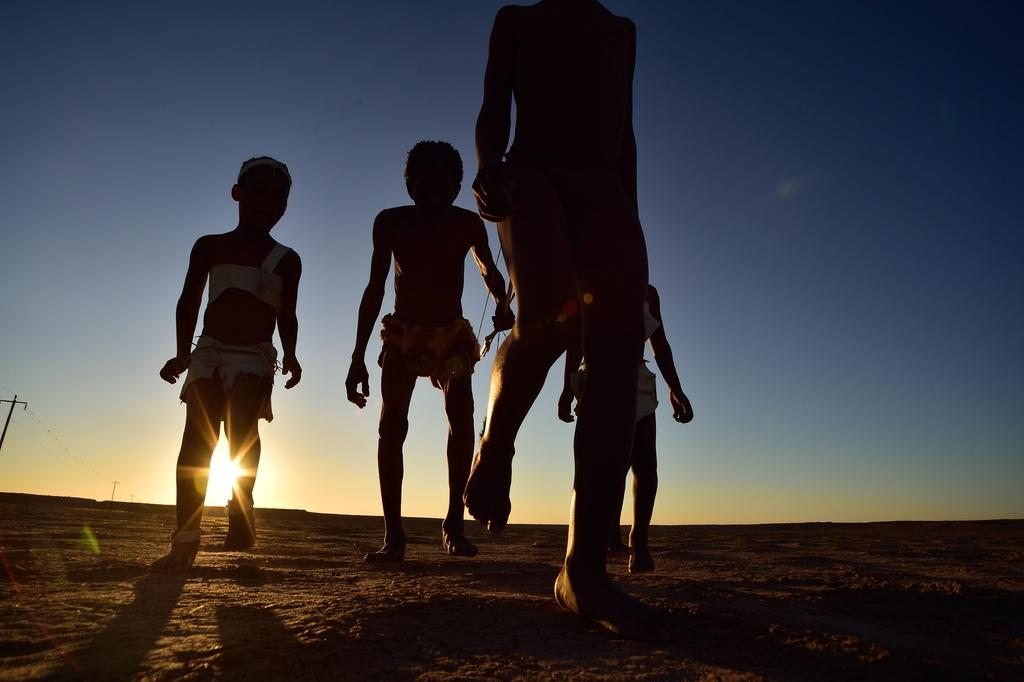What are the people in the image doing? The people in the image are walking on the ground. What can be seen in the background of the image? There is a current pole in the background of the image. What part of the natural environment is visible in the image? The sky is visible in the image. What type of basin is being used by the people in the image? There is no basin present in the image; the people are walking on the ground. What is the desire of the flag in the image? There is no flag present in the image, so it is not possible to determine any desires it might have. 